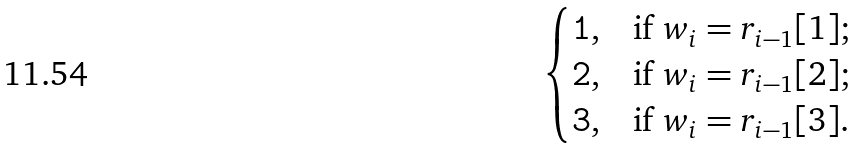<formula> <loc_0><loc_0><loc_500><loc_500>\begin{cases} \tt { 1 } , & \text {if $w_{i}=r_{i-1}[1]$} ; \\ \tt { 2 } , & \text {if $w_{i}=r_{i-1}[2]$} ; \\ \tt { 3 } , & \text {if $w_{i}=r_{i-1}[3]$} . \end{cases}</formula> 